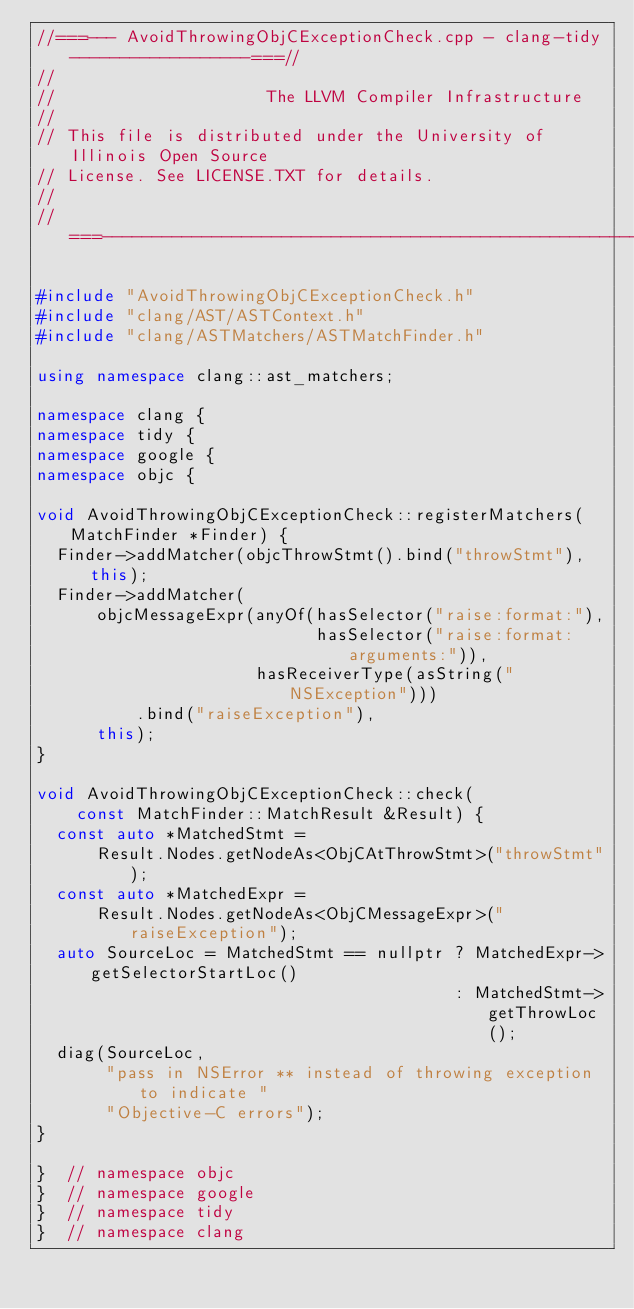Convert code to text. <code><loc_0><loc_0><loc_500><loc_500><_C++_>//===--- AvoidThrowingObjCExceptionCheck.cpp - clang-tidy------------------===//
//
//                     The LLVM Compiler Infrastructure
//
// This file is distributed under the University of Illinois Open Source
// License. See LICENSE.TXT for details.
//
//===----------------------------------------------------------------------===//

#include "AvoidThrowingObjCExceptionCheck.h"
#include "clang/AST/ASTContext.h"
#include "clang/ASTMatchers/ASTMatchFinder.h"

using namespace clang::ast_matchers;

namespace clang {
namespace tidy {
namespace google {
namespace objc {

void AvoidThrowingObjCExceptionCheck::registerMatchers(MatchFinder *Finder) {
  Finder->addMatcher(objcThrowStmt().bind("throwStmt"), this);
  Finder->addMatcher(
      objcMessageExpr(anyOf(hasSelector("raise:format:"),
                            hasSelector("raise:format:arguments:")),
                      hasReceiverType(asString("NSException")))
          .bind("raiseException"),
      this);
}

void AvoidThrowingObjCExceptionCheck::check(
    const MatchFinder::MatchResult &Result) {
  const auto *MatchedStmt =
      Result.Nodes.getNodeAs<ObjCAtThrowStmt>("throwStmt");
  const auto *MatchedExpr =
      Result.Nodes.getNodeAs<ObjCMessageExpr>("raiseException");
  auto SourceLoc = MatchedStmt == nullptr ? MatchedExpr->getSelectorStartLoc()
                                          : MatchedStmt->getThrowLoc();
  diag(SourceLoc,
       "pass in NSError ** instead of throwing exception to indicate "
       "Objective-C errors");
}

}  // namespace objc
}  // namespace google
}  // namespace tidy
}  // namespace clang
</code> 